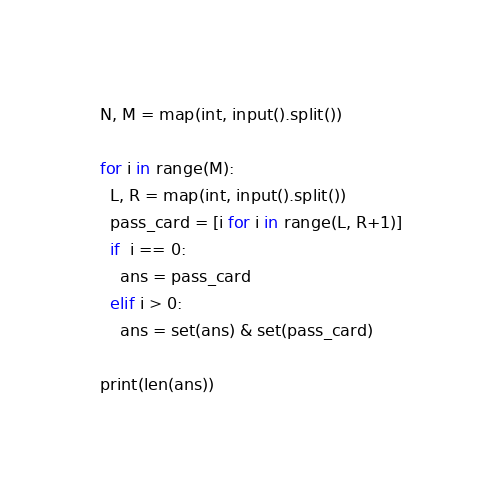Convert code to text. <code><loc_0><loc_0><loc_500><loc_500><_Python_>N, M = map(int, input().split())

for i in range(M):
  L, R = map(int, input().split())
  pass_card = [i for i in range(L, R+1)]
  if  i == 0:
    ans = pass_card
  elif i > 0:
    ans = set(ans) & set(pass_card)

print(len(ans))</code> 